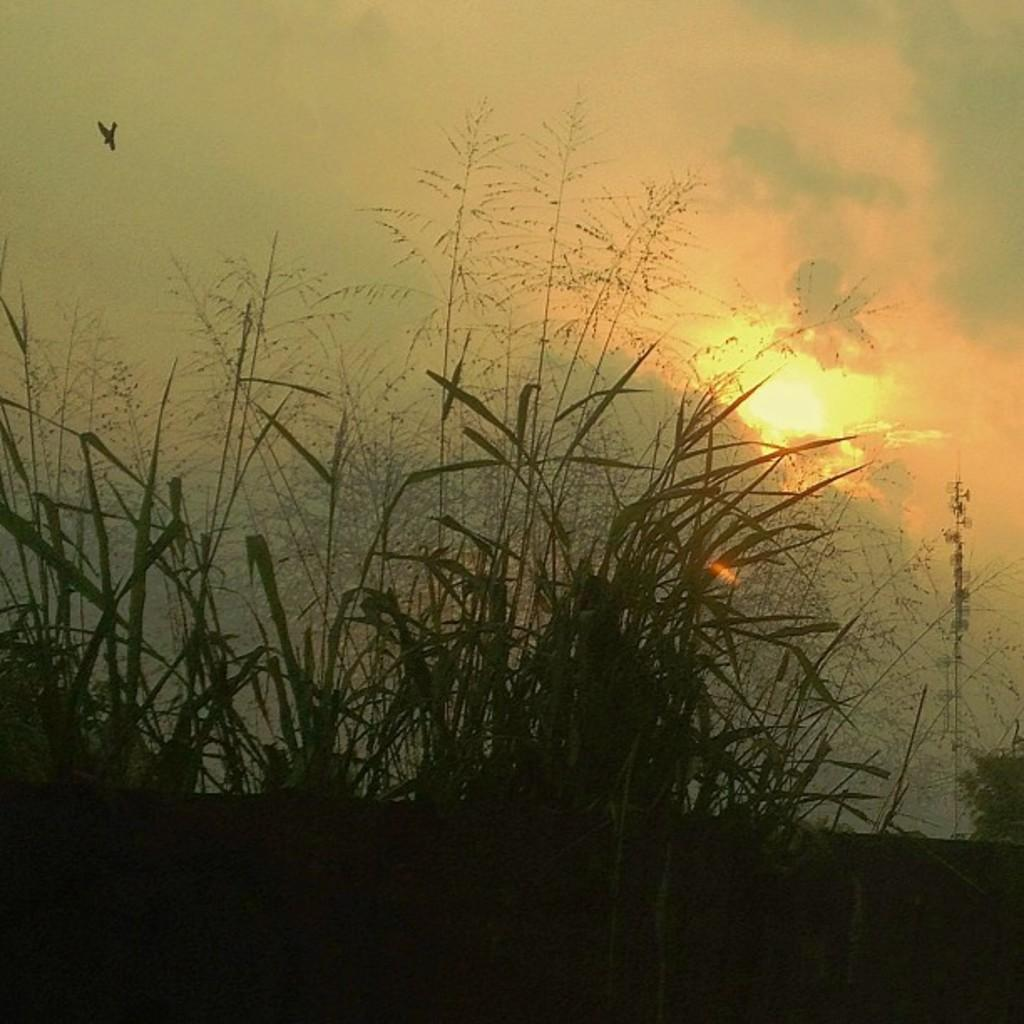What type of vegetation can be seen in the foreground of the image? There is green grass in the foreground of the image. What is the source of light in the image? Sunshine is visible in the image. What can be seen in the sky in the image? Clouds are present in the sky. What type of show is being performed in the image? There is no show or performance present in the image; it features green grass, sunshine, and clouds. 